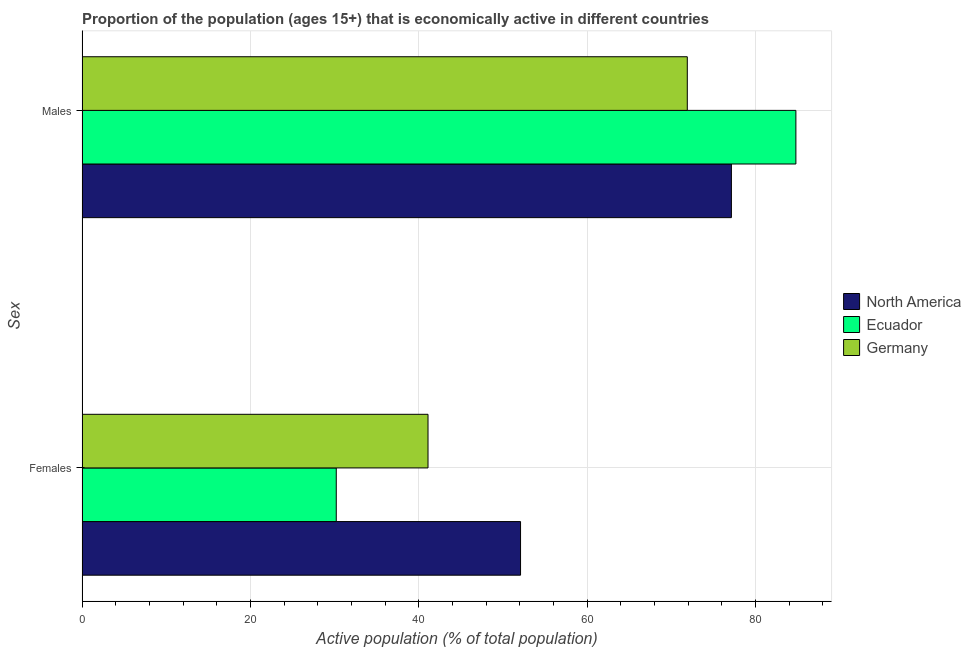How many different coloured bars are there?
Your answer should be compact. 3. How many groups of bars are there?
Your response must be concise. 2. Are the number of bars per tick equal to the number of legend labels?
Your response must be concise. Yes. Are the number of bars on each tick of the Y-axis equal?
Make the answer very short. Yes. How many bars are there on the 2nd tick from the top?
Provide a short and direct response. 3. How many bars are there on the 2nd tick from the bottom?
Give a very brief answer. 3. What is the label of the 1st group of bars from the top?
Give a very brief answer. Males. What is the percentage of economically active female population in Germany?
Your answer should be very brief. 41.1. Across all countries, what is the maximum percentage of economically active male population?
Give a very brief answer. 84.8. Across all countries, what is the minimum percentage of economically active female population?
Provide a succinct answer. 30.2. In which country was the percentage of economically active male population maximum?
Your response must be concise. Ecuador. What is the total percentage of economically active female population in the graph?
Make the answer very short. 123.39. What is the difference between the percentage of economically active male population in Germany and that in Ecuador?
Make the answer very short. -12.9. What is the difference between the percentage of economically active female population in Germany and the percentage of economically active male population in Ecuador?
Offer a terse response. -43.7. What is the average percentage of economically active female population per country?
Offer a very short reply. 41.13. What is the difference between the percentage of economically active female population and percentage of economically active male population in Germany?
Make the answer very short. -30.8. In how many countries, is the percentage of economically active male population greater than 12 %?
Your answer should be compact. 3. What is the ratio of the percentage of economically active male population in North America to that in Ecuador?
Give a very brief answer. 0.91. What does the 1st bar from the bottom in Males represents?
Make the answer very short. North America. Are all the bars in the graph horizontal?
Your answer should be compact. Yes. How many countries are there in the graph?
Your answer should be very brief. 3. What is the difference between two consecutive major ticks on the X-axis?
Your answer should be very brief. 20. Are the values on the major ticks of X-axis written in scientific E-notation?
Ensure brevity in your answer.  No. Does the graph contain grids?
Make the answer very short. Yes. How many legend labels are there?
Offer a very short reply. 3. What is the title of the graph?
Your response must be concise. Proportion of the population (ages 15+) that is economically active in different countries. Does "Japan" appear as one of the legend labels in the graph?
Ensure brevity in your answer.  No. What is the label or title of the X-axis?
Provide a succinct answer. Active population (% of total population). What is the label or title of the Y-axis?
Ensure brevity in your answer.  Sex. What is the Active population (% of total population) in North America in Females?
Make the answer very short. 52.09. What is the Active population (% of total population) of Ecuador in Females?
Your answer should be very brief. 30.2. What is the Active population (% of total population) in Germany in Females?
Provide a short and direct response. 41.1. What is the Active population (% of total population) in North America in Males?
Offer a terse response. 77.14. What is the Active population (% of total population) of Ecuador in Males?
Your answer should be compact. 84.8. What is the Active population (% of total population) in Germany in Males?
Your response must be concise. 71.9. Across all Sex, what is the maximum Active population (% of total population) in North America?
Provide a short and direct response. 77.14. Across all Sex, what is the maximum Active population (% of total population) in Ecuador?
Keep it short and to the point. 84.8. Across all Sex, what is the maximum Active population (% of total population) of Germany?
Your answer should be very brief. 71.9. Across all Sex, what is the minimum Active population (% of total population) of North America?
Provide a succinct answer. 52.09. Across all Sex, what is the minimum Active population (% of total population) in Ecuador?
Make the answer very short. 30.2. Across all Sex, what is the minimum Active population (% of total population) in Germany?
Ensure brevity in your answer.  41.1. What is the total Active population (% of total population) in North America in the graph?
Keep it short and to the point. 129.23. What is the total Active population (% of total population) of Ecuador in the graph?
Your answer should be compact. 115. What is the total Active population (% of total population) of Germany in the graph?
Make the answer very short. 113. What is the difference between the Active population (% of total population) of North America in Females and that in Males?
Provide a succinct answer. -25.05. What is the difference between the Active population (% of total population) in Ecuador in Females and that in Males?
Provide a succinct answer. -54.6. What is the difference between the Active population (% of total population) in Germany in Females and that in Males?
Provide a succinct answer. -30.8. What is the difference between the Active population (% of total population) in North America in Females and the Active population (% of total population) in Ecuador in Males?
Provide a short and direct response. -32.71. What is the difference between the Active population (% of total population) in North America in Females and the Active population (% of total population) in Germany in Males?
Make the answer very short. -19.81. What is the difference between the Active population (% of total population) in Ecuador in Females and the Active population (% of total population) in Germany in Males?
Offer a terse response. -41.7. What is the average Active population (% of total population) in North America per Sex?
Provide a short and direct response. 64.62. What is the average Active population (% of total population) of Ecuador per Sex?
Give a very brief answer. 57.5. What is the average Active population (% of total population) of Germany per Sex?
Offer a terse response. 56.5. What is the difference between the Active population (% of total population) in North America and Active population (% of total population) in Ecuador in Females?
Ensure brevity in your answer.  21.89. What is the difference between the Active population (% of total population) in North America and Active population (% of total population) in Germany in Females?
Your response must be concise. 10.99. What is the difference between the Active population (% of total population) in Ecuador and Active population (% of total population) in Germany in Females?
Provide a succinct answer. -10.9. What is the difference between the Active population (% of total population) in North America and Active population (% of total population) in Ecuador in Males?
Offer a very short reply. -7.66. What is the difference between the Active population (% of total population) in North America and Active population (% of total population) in Germany in Males?
Make the answer very short. 5.24. What is the difference between the Active population (% of total population) in Ecuador and Active population (% of total population) in Germany in Males?
Provide a succinct answer. 12.9. What is the ratio of the Active population (% of total population) of North America in Females to that in Males?
Offer a very short reply. 0.68. What is the ratio of the Active population (% of total population) in Ecuador in Females to that in Males?
Offer a very short reply. 0.36. What is the ratio of the Active population (% of total population) of Germany in Females to that in Males?
Offer a very short reply. 0.57. What is the difference between the highest and the second highest Active population (% of total population) in North America?
Make the answer very short. 25.05. What is the difference between the highest and the second highest Active population (% of total population) of Ecuador?
Provide a succinct answer. 54.6. What is the difference between the highest and the second highest Active population (% of total population) of Germany?
Keep it short and to the point. 30.8. What is the difference between the highest and the lowest Active population (% of total population) of North America?
Ensure brevity in your answer.  25.05. What is the difference between the highest and the lowest Active population (% of total population) in Ecuador?
Offer a very short reply. 54.6. What is the difference between the highest and the lowest Active population (% of total population) in Germany?
Make the answer very short. 30.8. 